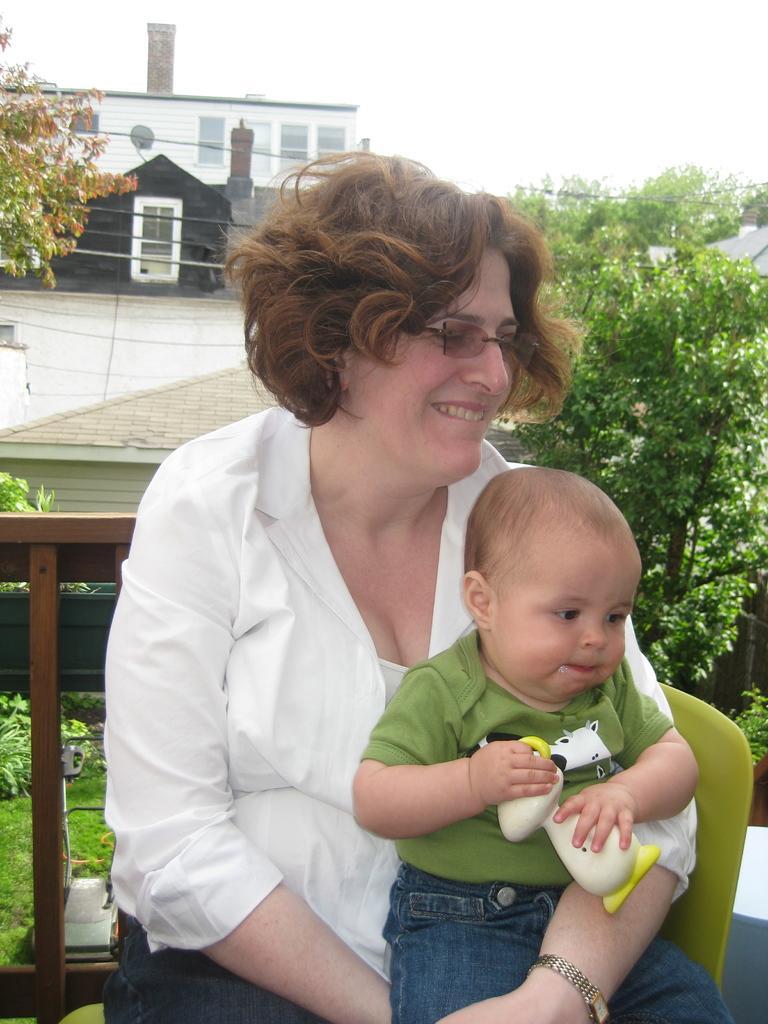Can you describe this image briefly? This picture is clicked outside. In the foreground we can see a woman wearing white color dress, smiling, holding a toddler and sitting on the chair and we can see a toddler holding a toy, wearing a t-shirt and sitting on the lap of a woman. In the background we can see the sky, buildings, trees, green grass, plants and some other objects. 